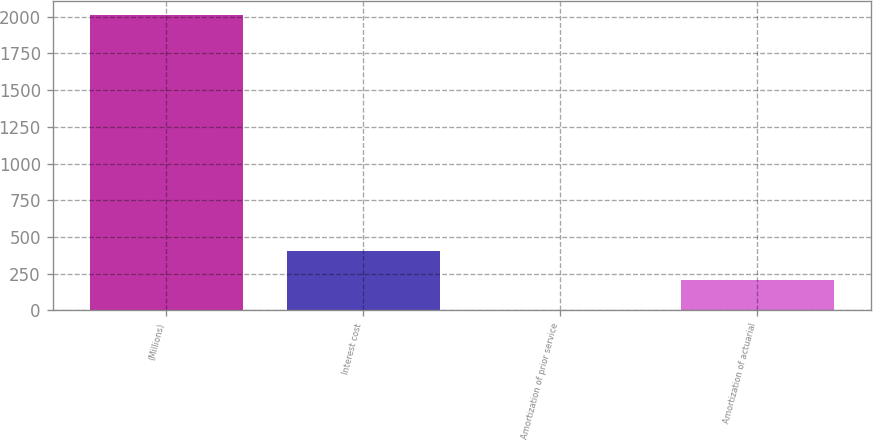Convert chart. <chart><loc_0><loc_0><loc_500><loc_500><bar_chart><fcel>(Millions)<fcel>Interest cost<fcel>Amortization of prior service<fcel>Amortization of actuarial<nl><fcel>2010<fcel>406<fcel>5<fcel>205.5<nl></chart> 